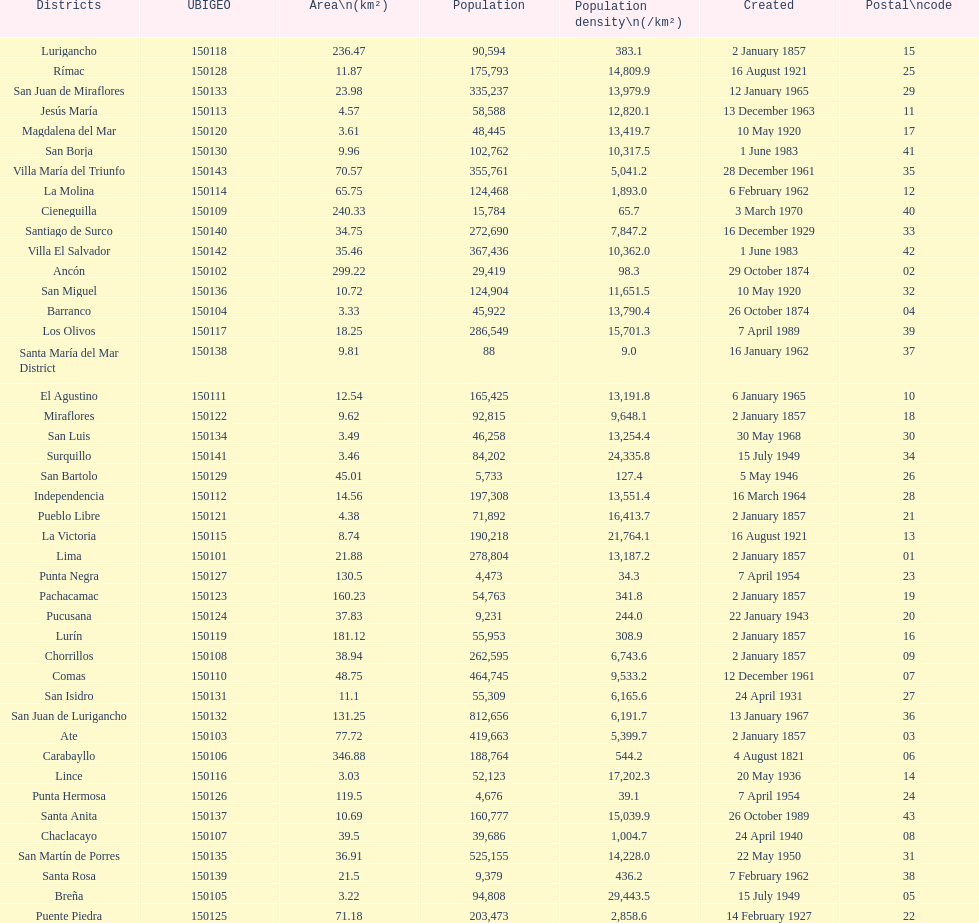Which is the largest district in terms of population? San Juan de Lurigancho. 